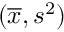Convert formula to latex. <formula><loc_0><loc_0><loc_500><loc_500>( { \overline { x } } , s ^ { 2 } )</formula> 